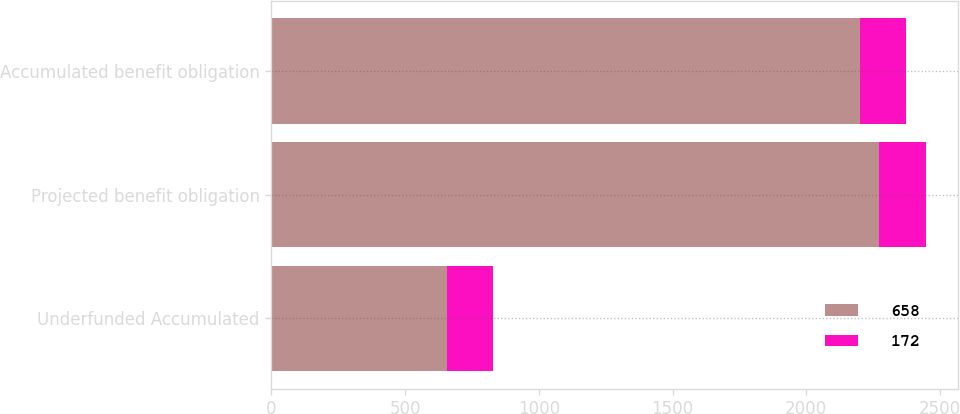Convert chart. <chart><loc_0><loc_0><loc_500><loc_500><stacked_bar_chart><ecel><fcel>Underfunded Accumulated<fcel>Projected benefit obligation<fcel>Accumulated benefit obligation<nl><fcel>658<fcel>658<fcel>2272<fcel>2201<nl><fcel>172<fcel>172<fcel>175<fcel>172<nl></chart> 